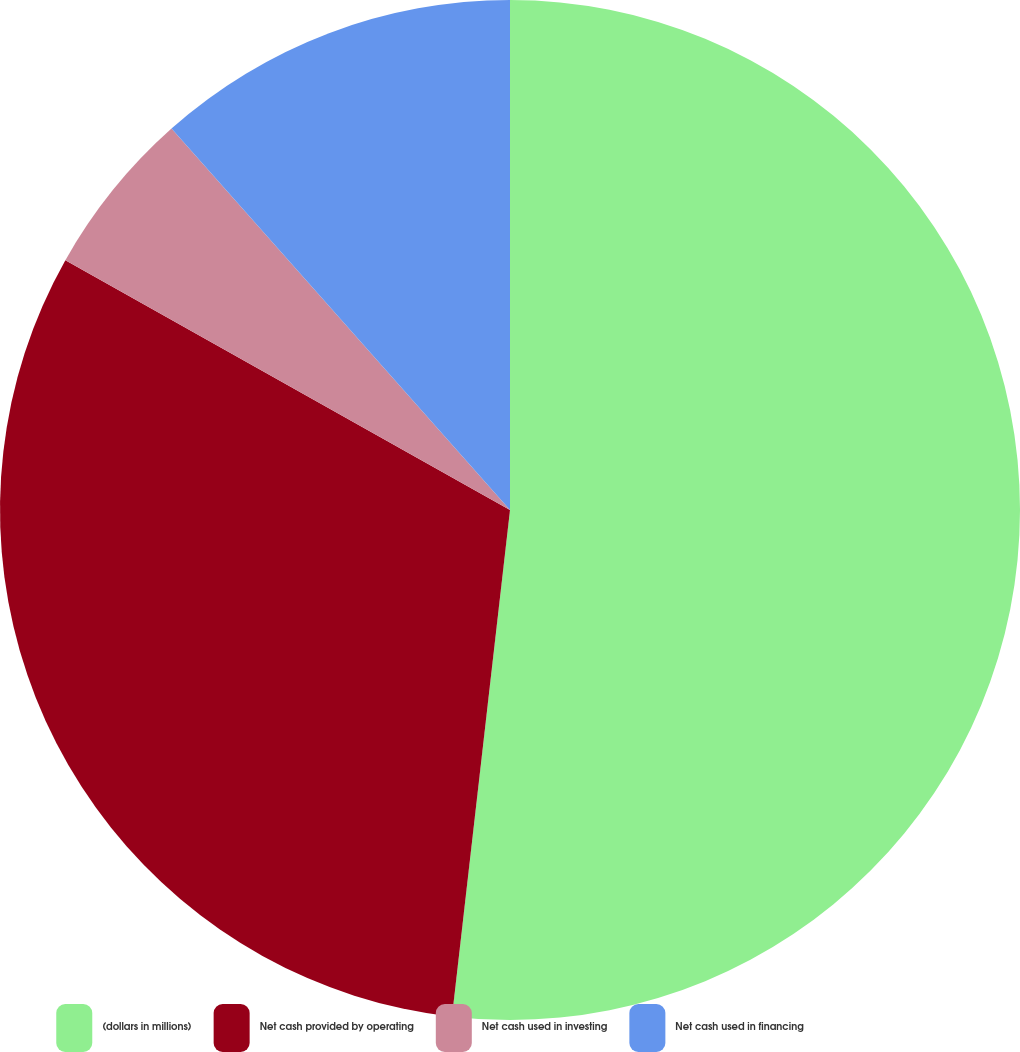Convert chart to OTSL. <chart><loc_0><loc_0><loc_500><loc_500><pie_chart><fcel>(dollars in millions)<fcel>Net cash provided by operating<fcel>Net cash used in investing<fcel>Net cash used in financing<nl><fcel>51.81%<fcel>31.33%<fcel>5.3%<fcel>11.55%<nl></chart> 